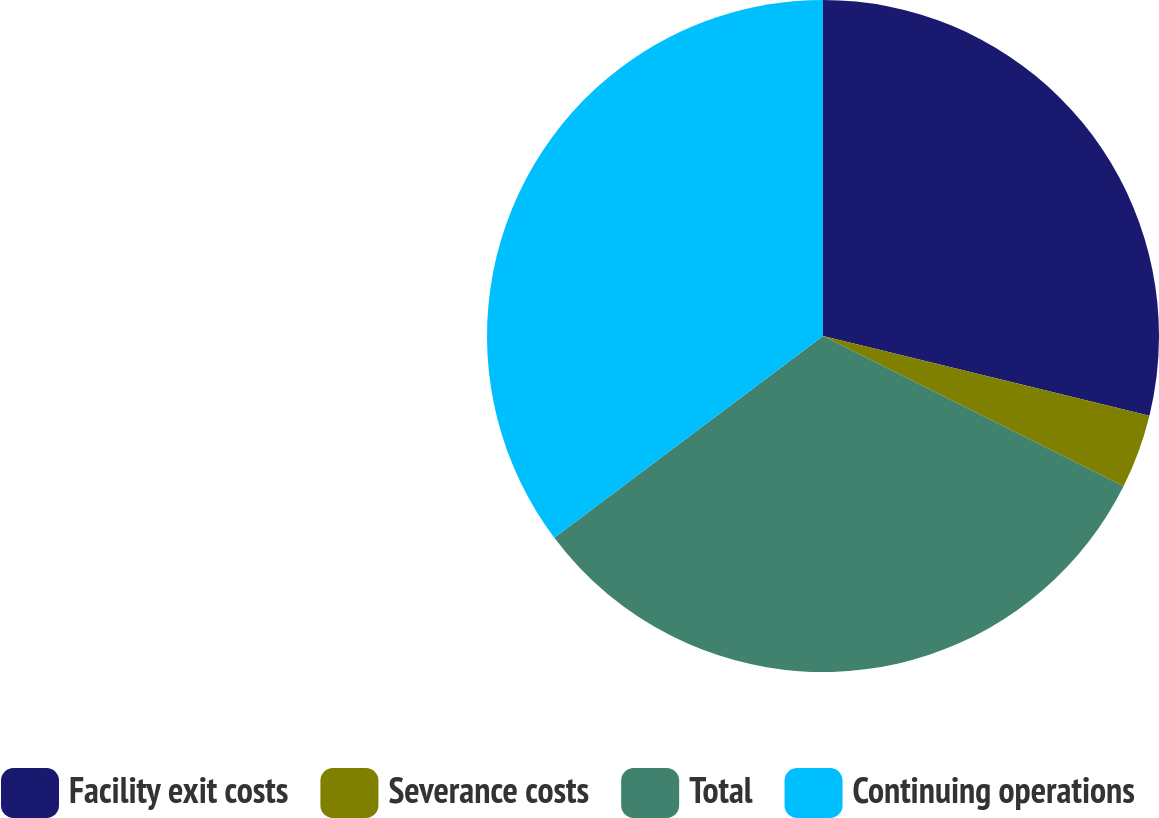Convert chart. <chart><loc_0><loc_0><loc_500><loc_500><pie_chart><fcel>Facility exit costs<fcel>Severance costs<fcel>Total<fcel>Continuing operations<nl><fcel>28.81%<fcel>3.57%<fcel>32.37%<fcel>35.25%<nl></chart> 